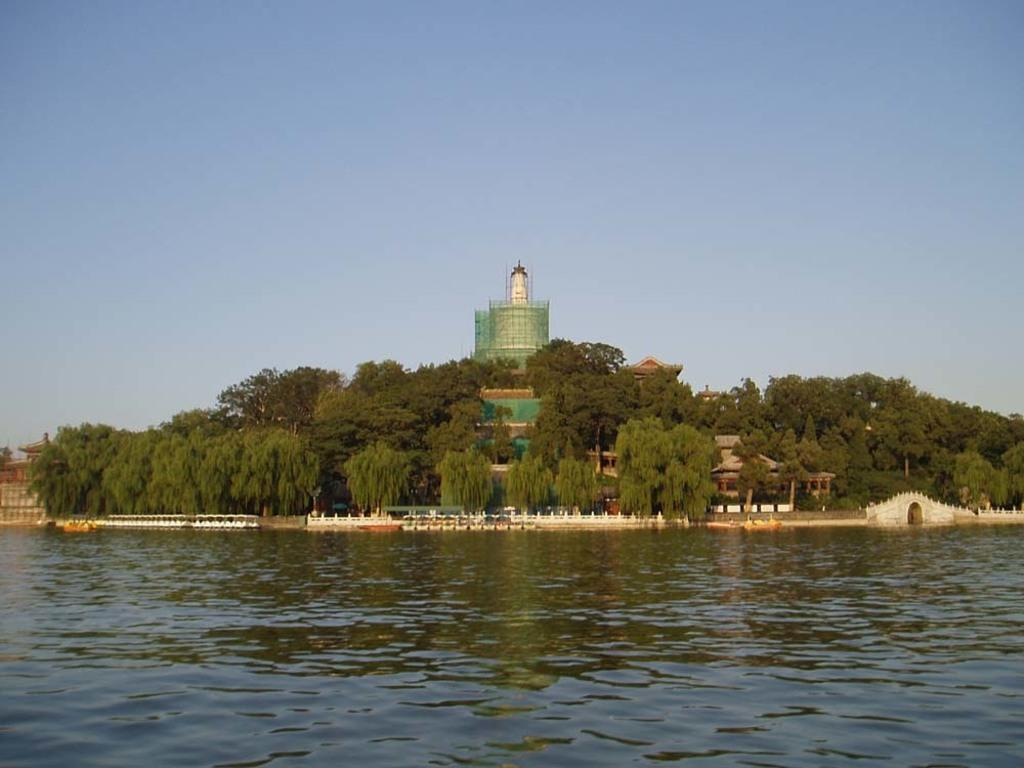What type of structure is present in the image? There is a building in the image. What natural elements can be seen in the image? There is a group of trees and water visible in the image. What part of the natural environment is visible in the image? The sky is visible in the image. How would you describe the sky in the image? The sky appears cloudy in the image. Can you tell me how many people are experiencing pain in the image? There is no indication of pain or any people in the image. Is there any mist visible in the image? There is no mist present in the image; it only shows a building, trees, water, and a cloudy sky. 